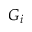<formula> <loc_0><loc_0><loc_500><loc_500>G _ { i }</formula> 